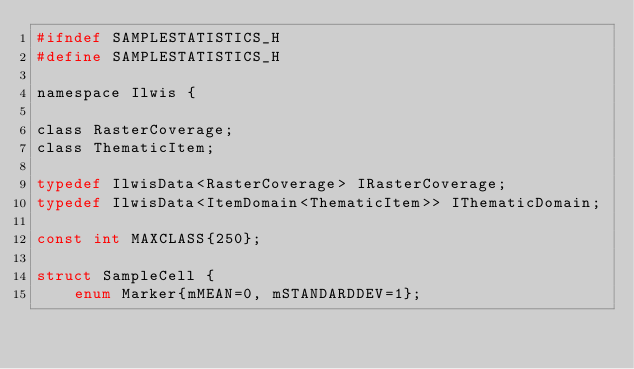Convert code to text. <code><loc_0><loc_0><loc_500><loc_500><_C_>#ifndef SAMPLESTATISTICS_H
#define SAMPLESTATISTICS_H

namespace Ilwis {

class RasterCoverage;
class ThematicItem;

typedef IlwisData<RasterCoverage> IRasterCoverage;
typedef IlwisData<ItemDomain<ThematicItem>> IThematicDomain;

const int MAXCLASS{250};

struct SampleCell {
    enum Marker{mMEAN=0, mSTANDARDDEV=1};
</code> 